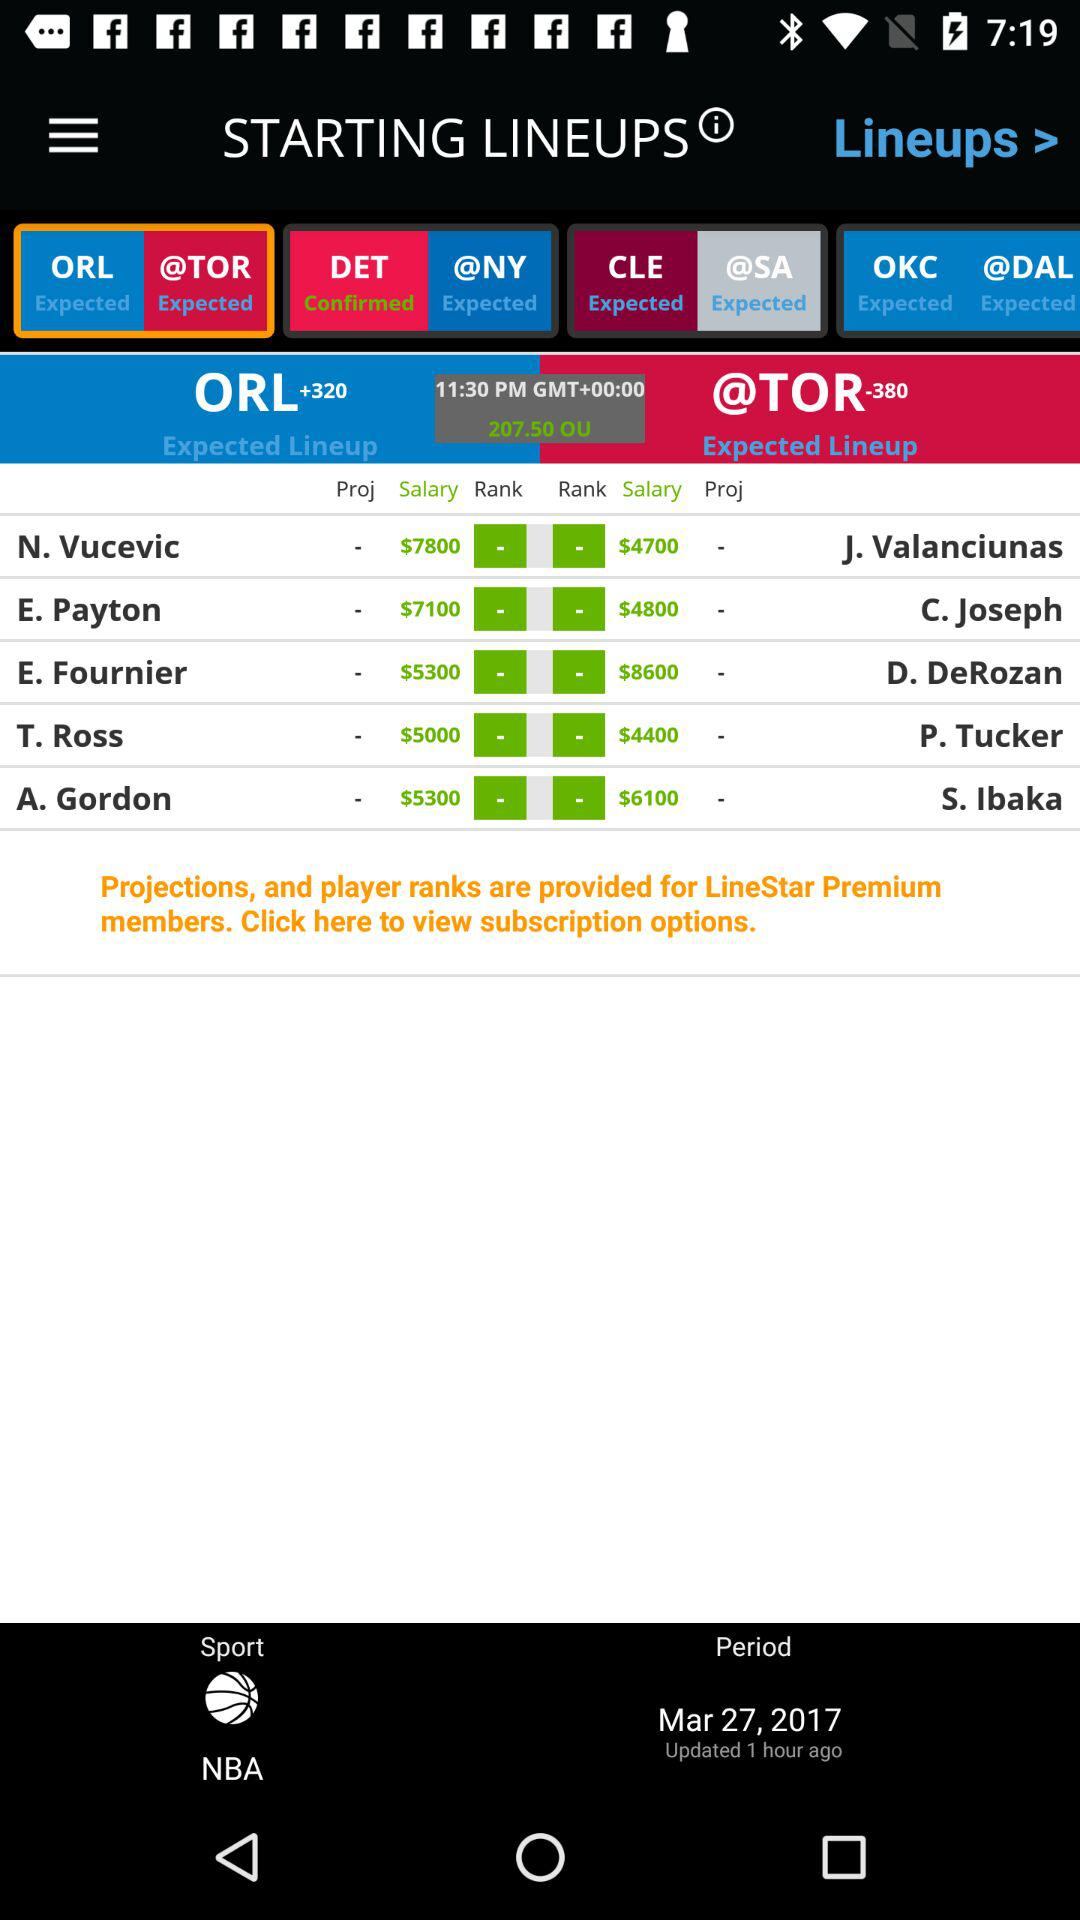How many hours ago was the update done? The update was done 1 hour ago. 